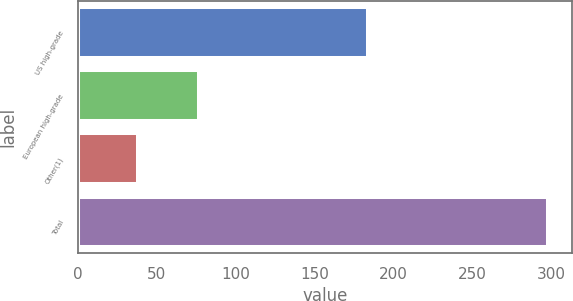Convert chart to OTSL. <chart><loc_0><loc_0><loc_500><loc_500><bar_chart><fcel>US high-grade<fcel>European high-grade<fcel>Other(1)<fcel>Total<nl><fcel>183.5<fcel>76.5<fcel>38.1<fcel>298.1<nl></chart> 